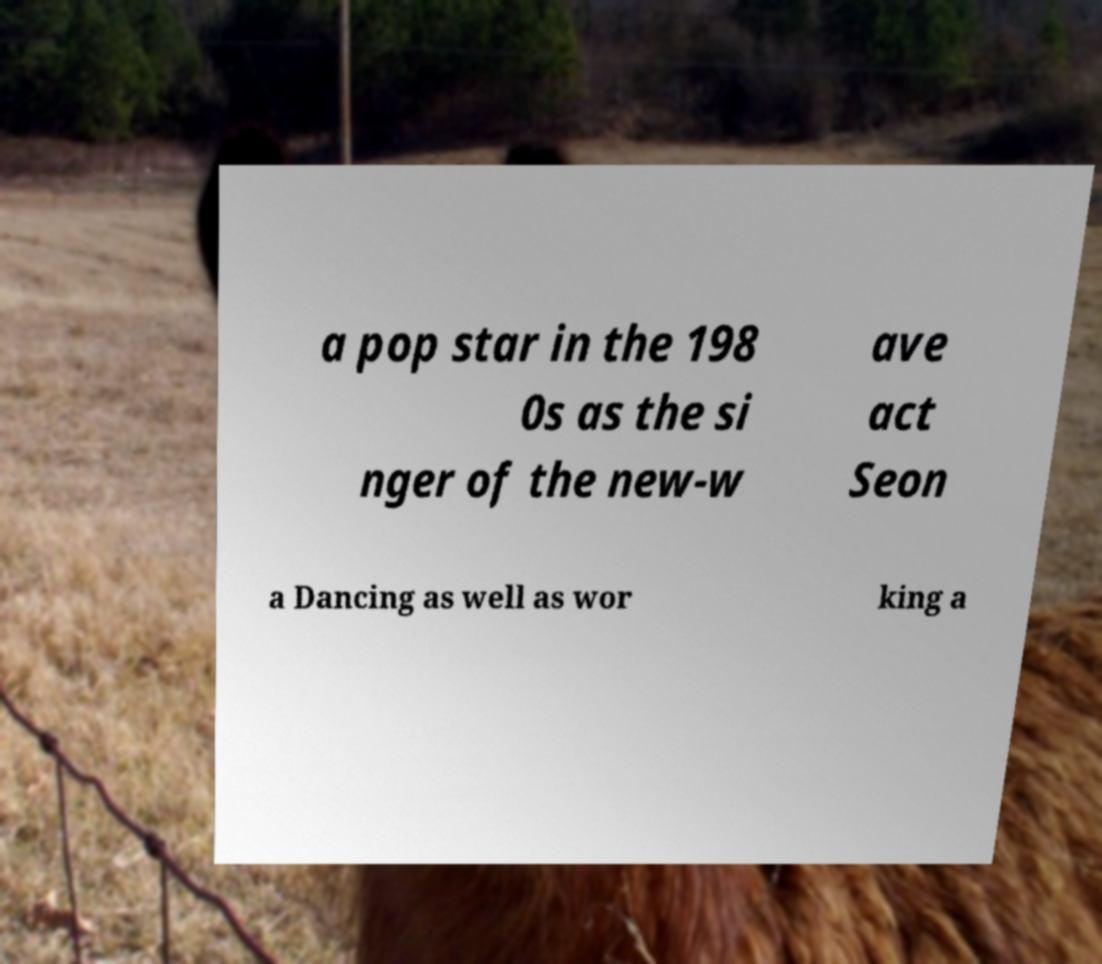Can you accurately transcribe the text from the provided image for me? a pop star in the 198 0s as the si nger of the new-w ave act Seon a Dancing as well as wor king a 